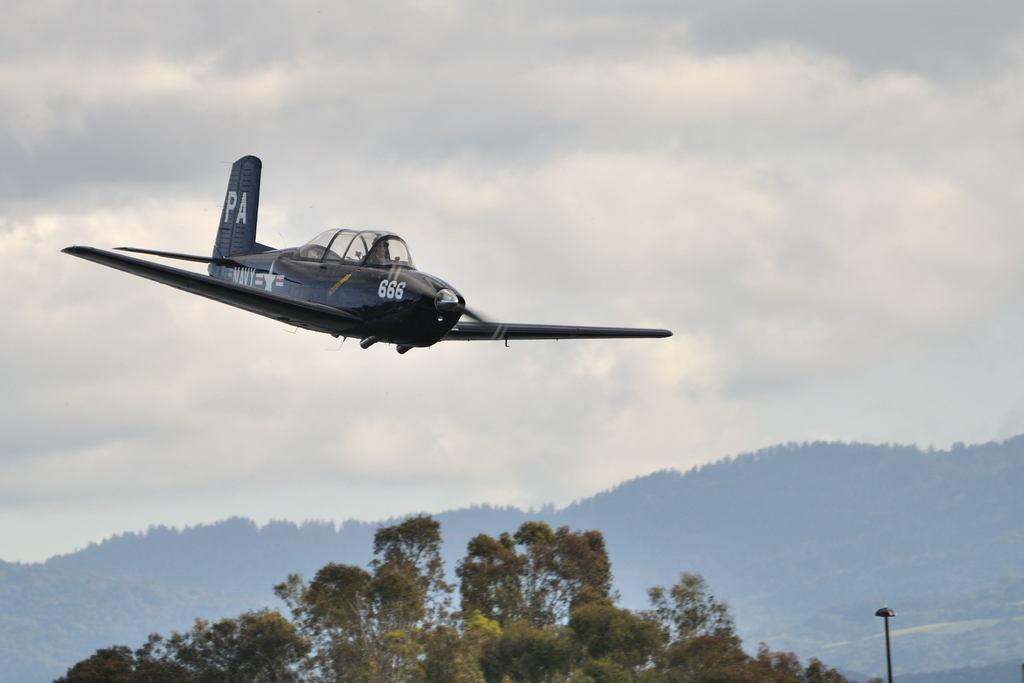Please provide a concise description of this image. In this image there is the sky towards the top of the image, there are clouds in the sky, there is an airplane, there is text on the airplane, there is a number on the airplane, there are mountains, there is a tree towards the bottom of the image, there is a pole towards the bottom of the image, there is a light. 